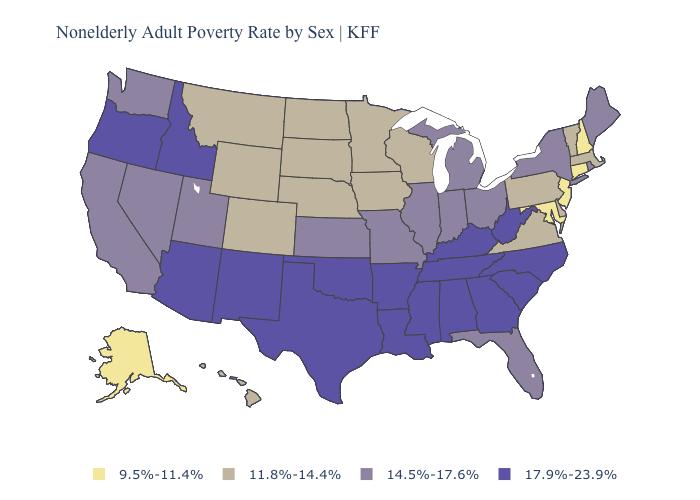Name the states that have a value in the range 14.5%-17.6%?
Concise answer only. California, Florida, Illinois, Indiana, Kansas, Maine, Michigan, Missouri, Nevada, New York, Ohio, Rhode Island, Utah, Washington. Does the first symbol in the legend represent the smallest category?
Answer briefly. Yes. Name the states that have a value in the range 9.5%-11.4%?
Be succinct. Alaska, Connecticut, Maryland, New Hampshire, New Jersey. What is the value of Arkansas?
Give a very brief answer. 17.9%-23.9%. How many symbols are there in the legend?
Give a very brief answer. 4. Name the states that have a value in the range 11.8%-14.4%?
Keep it brief. Colorado, Delaware, Hawaii, Iowa, Massachusetts, Minnesota, Montana, Nebraska, North Dakota, Pennsylvania, South Dakota, Vermont, Virginia, Wisconsin, Wyoming. Among the states that border Oregon , which have the lowest value?
Write a very short answer. California, Nevada, Washington. Is the legend a continuous bar?
Quick response, please. No. What is the value of Tennessee?
Give a very brief answer. 17.9%-23.9%. Among the states that border Nevada , which have the highest value?
Be succinct. Arizona, Idaho, Oregon. Name the states that have a value in the range 9.5%-11.4%?
Give a very brief answer. Alaska, Connecticut, Maryland, New Hampshire, New Jersey. What is the value of Mississippi?
Short answer required. 17.9%-23.9%. Among the states that border Michigan , does Indiana have the lowest value?
Answer briefly. No. Does Connecticut have the highest value in the Northeast?
Be succinct. No. What is the value of Kentucky?
Short answer required. 17.9%-23.9%. 